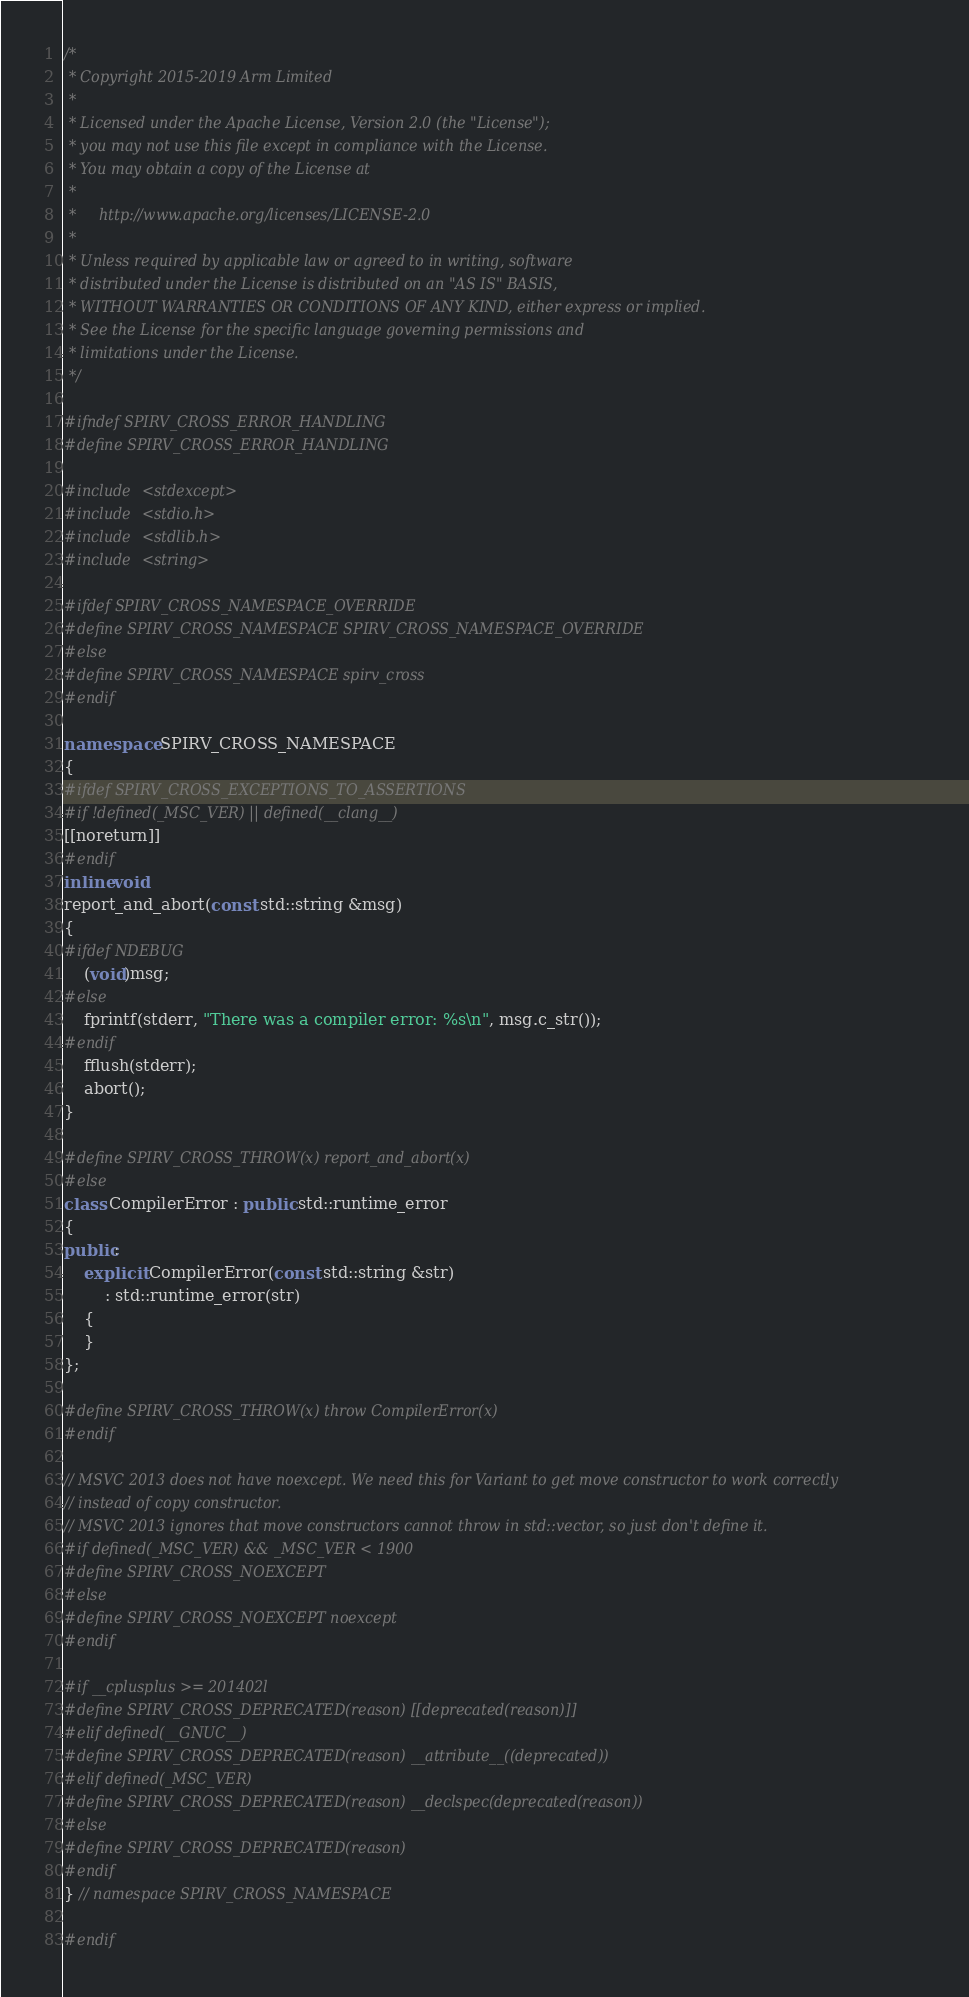<code> <loc_0><loc_0><loc_500><loc_500><_C++_>/*
 * Copyright 2015-2019 Arm Limited
 *
 * Licensed under the Apache License, Version 2.0 (the "License");
 * you may not use this file except in compliance with the License.
 * You may obtain a copy of the License at
 *
 *     http://www.apache.org/licenses/LICENSE-2.0
 *
 * Unless required by applicable law or agreed to in writing, software
 * distributed under the License is distributed on an "AS IS" BASIS,
 * WITHOUT WARRANTIES OR CONDITIONS OF ANY KIND, either express or implied.
 * See the License for the specific language governing permissions and
 * limitations under the License.
 */

#ifndef SPIRV_CROSS_ERROR_HANDLING
#define SPIRV_CROSS_ERROR_HANDLING

#include <stdexcept>
#include <stdio.h>
#include <stdlib.h>
#include <string>

#ifdef SPIRV_CROSS_NAMESPACE_OVERRIDE
#define SPIRV_CROSS_NAMESPACE SPIRV_CROSS_NAMESPACE_OVERRIDE
#else
#define SPIRV_CROSS_NAMESPACE spirv_cross
#endif

namespace SPIRV_CROSS_NAMESPACE
{
#ifdef SPIRV_CROSS_EXCEPTIONS_TO_ASSERTIONS
#if !defined(_MSC_VER) || defined(__clang__)
[[noreturn]]
#endif
inline void
report_and_abort(const std::string &msg)
{
#ifdef NDEBUG
	(void)msg;
#else
	fprintf(stderr, "There was a compiler error: %s\n", msg.c_str());
#endif
	fflush(stderr);
	abort();
}

#define SPIRV_CROSS_THROW(x) report_and_abort(x)
#else
class CompilerError : public std::runtime_error
{
public:
	explicit CompilerError(const std::string &str)
	    : std::runtime_error(str)
	{
	}
};

#define SPIRV_CROSS_THROW(x) throw CompilerError(x)
#endif

// MSVC 2013 does not have noexcept. We need this for Variant to get move constructor to work correctly
// instead of copy constructor.
// MSVC 2013 ignores that move constructors cannot throw in std::vector, so just don't define it.
#if defined(_MSC_VER) && _MSC_VER < 1900
#define SPIRV_CROSS_NOEXCEPT
#else
#define SPIRV_CROSS_NOEXCEPT noexcept
#endif

#if __cplusplus >= 201402l
#define SPIRV_CROSS_DEPRECATED(reason) [[deprecated(reason)]]
#elif defined(__GNUC__)
#define SPIRV_CROSS_DEPRECATED(reason) __attribute__((deprecated))
#elif defined(_MSC_VER)
#define SPIRV_CROSS_DEPRECATED(reason) __declspec(deprecated(reason))
#else
#define SPIRV_CROSS_DEPRECATED(reason)
#endif
} // namespace SPIRV_CROSS_NAMESPACE

#endif
</code> 